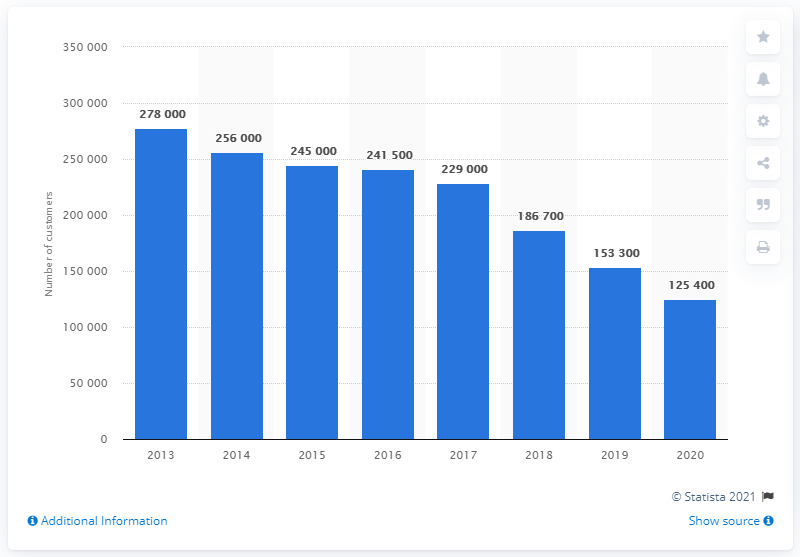Identify some key points in this picture. In 2020, the number of customers of Yellow Pages Canada was 125,400. 